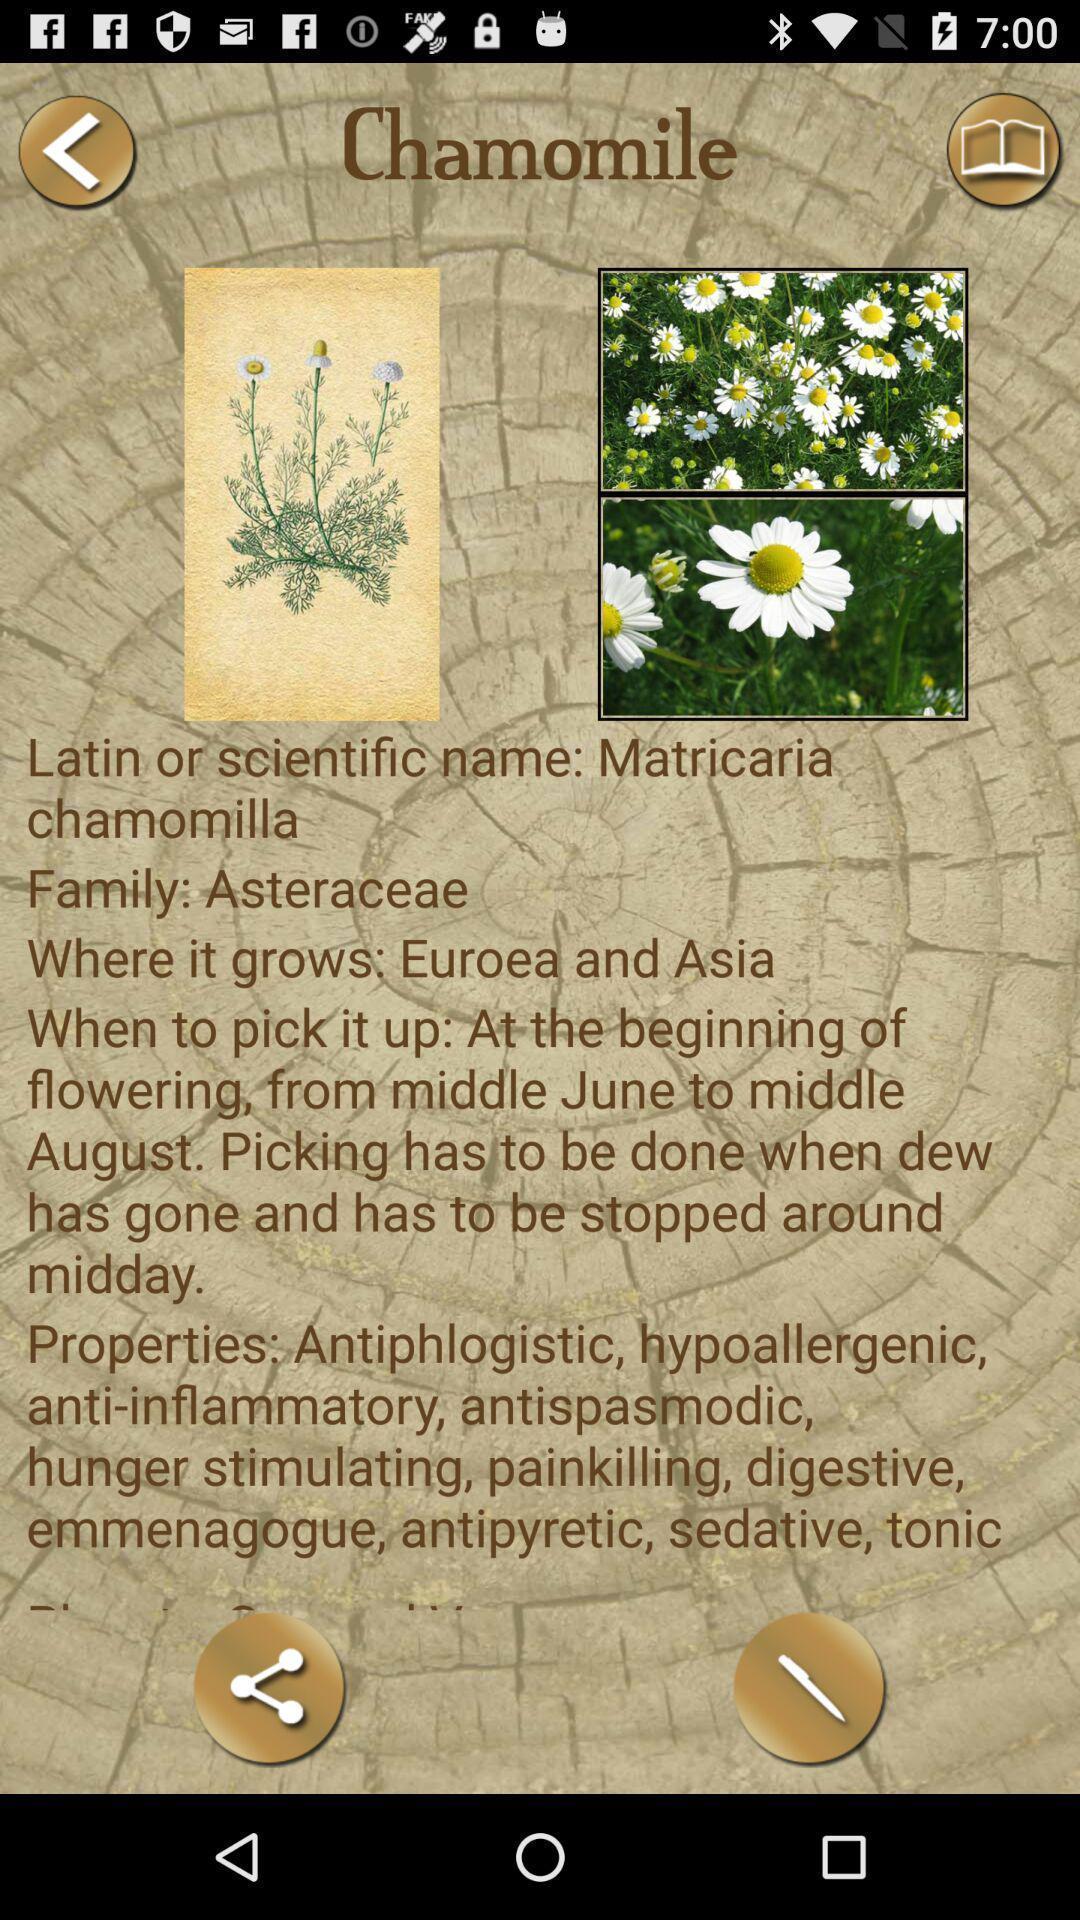Provide a detailed account of this screenshot. Screen showing page of application with share option. 